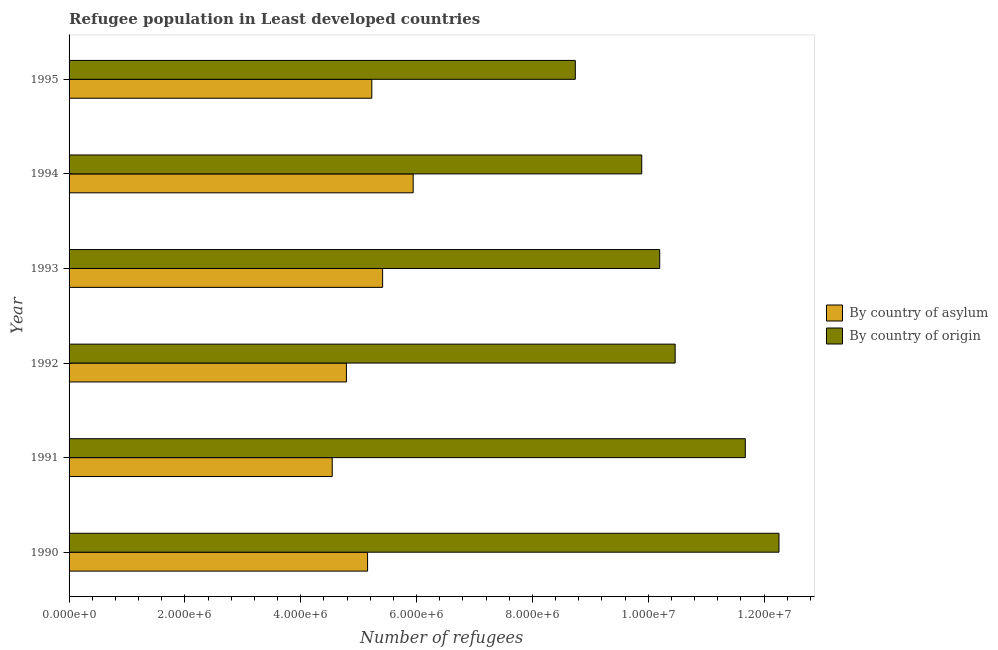How many different coloured bars are there?
Provide a succinct answer. 2. Are the number of bars per tick equal to the number of legend labels?
Your response must be concise. Yes. In how many cases, is the number of bars for a given year not equal to the number of legend labels?
Your answer should be compact. 0. What is the number of refugees by country of asylum in 1990?
Your answer should be very brief. 5.15e+06. Across all years, what is the maximum number of refugees by country of asylum?
Your response must be concise. 5.94e+06. Across all years, what is the minimum number of refugees by country of origin?
Keep it short and to the point. 8.74e+06. What is the total number of refugees by country of origin in the graph?
Provide a succinct answer. 6.32e+07. What is the difference between the number of refugees by country of origin in 1990 and that in 1995?
Your answer should be very brief. 3.52e+06. What is the difference between the number of refugees by country of asylum in 1990 and the number of refugees by country of origin in 1994?
Offer a terse response. -4.73e+06. What is the average number of refugees by country of asylum per year?
Offer a very short reply. 5.18e+06. In the year 1991, what is the difference between the number of refugees by country of asylum and number of refugees by country of origin?
Give a very brief answer. -7.13e+06. In how many years, is the number of refugees by country of asylum greater than 2800000 ?
Your answer should be compact. 6. What is the difference between the highest and the second highest number of refugees by country of asylum?
Your answer should be very brief. 5.27e+05. What is the difference between the highest and the lowest number of refugees by country of origin?
Ensure brevity in your answer.  3.52e+06. What does the 2nd bar from the top in 1991 represents?
Your answer should be very brief. By country of asylum. What does the 2nd bar from the bottom in 1995 represents?
Ensure brevity in your answer.  By country of origin. How many bars are there?
Your response must be concise. 12. Are all the bars in the graph horizontal?
Ensure brevity in your answer.  Yes. Does the graph contain any zero values?
Your answer should be very brief. No. Does the graph contain grids?
Provide a succinct answer. No. Where does the legend appear in the graph?
Offer a very short reply. Center right. How many legend labels are there?
Provide a succinct answer. 2. How are the legend labels stacked?
Offer a terse response. Vertical. What is the title of the graph?
Offer a terse response. Refugee population in Least developed countries. What is the label or title of the X-axis?
Give a very brief answer. Number of refugees. What is the label or title of the Y-axis?
Offer a very short reply. Year. What is the Number of refugees in By country of asylum in 1990?
Your answer should be compact. 5.15e+06. What is the Number of refugees in By country of origin in 1990?
Make the answer very short. 1.23e+07. What is the Number of refugees of By country of asylum in 1991?
Keep it short and to the point. 4.54e+06. What is the Number of refugees in By country of origin in 1991?
Offer a terse response. 1.17e+07. What is the Number of refugees in By country of asylum in 1992?
Offer a terse response. 4.79e+06. What is the Number of refugees of By country of origin in 1992?
Your answer should be compact. 1.05e+07. What is the Number of refugees of By country of asylum in 1993?
Your answer should be compact. 5.41e+06. What is the Number of refugees of By country of origin in 1993?
Ensure brevity in your answer.  1.02e+07. What is the Number of refugees in By country of asylum in 1994?
Provide a short and direct response. 5.94e+06. What is the Number of refugees in By country of origin in 1994?
Provide a short and direct response. 9.89e+06. What is the Number of refugees of By country of asylum in 1995?
Provide a succinct answer. 5.23e+06. What is the Number of refugees of By country of origin in 1995?
Give a very brief answer. 8.74e+06. Across all years, what is the maximum Number of refugees of By country of asylum?
Offer a very short reply. 5.94e+06. Across all years, what is the maximum Number of refugees in By country of origin?
Offer a terse response. 1.23e+07. Across all years, what is the minimum Number of refugees of By country of asylum?
Offer a very short reply. 4.54e+06. Across all years, what is the minimum Number of refugees of By country of origin?
Give a very brief answer. 8.74e+06. What is the total Number of refugees of By country of asylum in the graph?
Provide a short and direct response. 3.11e+07. What is the total Number of refugees of By country of origin in the graph?
Ensure brevity in your answer.  6.32e+07. What is the difference between the Number of refugees of By country of asylum in 1990 and that in 1991?
Keep it short and to the point. 6.10e+05. What is the difference between the Number of refugees in By country of origin in 1990 and that in 1991?
Provide a short and direct response. 5.82e+05. What is the difference between the Number of refugees in By country of asylum in 1990 and that in 1992?
Offer a terse response. 3.65e+05. What is the difference between the Number of refugees of By country of origin in 1990 and that in 1992?
Provide a succinct answer. 1.79e+06. What is the difference between the Number of refugees of By country of asylum in 1990 and that in 1993?
Provide a short and direct response. -2.60e+05. What is the difference between the Number of refugees of By country of origin in 1990 and that in 1993?
Provide a short and direct response. 2.06e+06. What is the difference between the Number of refugees in By country of asylum in 1990 and that in 1994?
Offer a very short reply. -7.87e+05. What is the difference between the Number of refugees in By country of origin in 1990 and that in 1994?
Make the answer very short. 2.37e+06. What is the difference between the Number of refugees of By country of asylum in 1990 and that in 1995?
Make the answer very short. -7.28e+04. What is the difference between the Number of refugees in By country of origin in 1990 and that in 1995?
Make the answer very short. 3.52e+06. What is the difference between the Number of refugees in By country of asylum in 1991 and that in 1992?
Provide a short and direct response. -2.45e+05. What is the difference between the Number of refugees of By country of origin in 1991 and that in 1992?
Ensure brevity in your answer.  1.21e+06. What is the difference between the Number of refugees of By country of asylum in 1991 and that in 1993?
Offer a terse response. -8.70e+05. What is the difference between the Number of refugees in By country of origin in 1991 and that in 1993?
Ensure brevity in your answer.  1.48e+06. What is the difference between the Number of refugees of By country of asylum in 1991 and that in 1994?
Offer a terse response. -1.40e+06. What is the difference between the Number of refugees in By country of origin in 1991 and that in 1994?
Your response must be concise. 1.79e+06. What is the difference between the Number of refugees in By country of asylum in 1991 and that in 1995?
Give a very brief answer. -6.83e+05. What is the difference between the Number of refugees of By country of origin in 1991 and that in 1995?
Make the answer very short. 2.94e+06. What is the difference between the Number of refugees of By country of asylum in 1992 and that in 1993?
Make the answer very short. -6.25e+05. What is the difference between the Number of refugees in By country of origin in 1992 and that in 1993?
Give a very brief answer. 2.67e+05. What is the difference between the Number of refugees of By country of asylum in 1992 and that in 1994?
Ensure brevity in your answer.  -1.15e+06. What is the difference between the Number of refugees of By country of origin in 1992 and that in 1994?
Offer a terse response. 5.77e+05. What is the difference between the Number of refugees of By country of asylum in 1992 and that in 1995?
Offer a very short reply. -4.38e+05. What is the difference between the Number of refugees in By country of origin in 1992 and that in 1995?
Keep it short and to the point. 1.72e+06. What is the difference between the Number of refugees in By country of asylum in 1993 and that in 1994?
Offer a very short reply. -5.27e+05. What is the difference between the Number of refugees in By country of origin in 1993 and that in 1994?
Provide a succinct answer. 3.10e+05. What is the difference between the Number of refugees in By country of asylum in 1993 and that in 1995?
Offer a very short reply. 1.87e+05. What is the difference between the Number of refugees of By country of origin in 1993 and that in 1995?
Offer a terse response. 1.46e+06. What is the difference between the Number of refugees of By country of asylum in 1994 and that in 1995?
Provide a short and direct response. 7.15e+05. What is the difference between the Number of refugees of By country of origin in 1994 and that in 1995?
Your answer should be very brief. 1.15e+06. What is the difference between the Number of refugees of By country of asylum in 1990 and the Number of refugees of By country of origin in 1991?
Provide a short and direct response. -6.52e+06. What is the difference between the Number of refugees of By country of asylum in 1990 and the Number of refugees of By country of origin in 1992?
Your answer should be very brief. -5.31e+06. What is the difference between the Number of refugees in By country of asylum in 1990 and the Number of refugees in By country of origin in 1993?
Provide a short and direct response. -5.04e+06. What is the difference between the Number of refugees of By country of asylum in 1990 and the Number of refugees of By country of origin in 1994?
Keep it short and to the point. -4.73e+06. What is the difference between the Number of refugees in By country of asylum in 1990 and the Number of refugees in By country of origin in 1995?
Your answer should be compact. -3.59e+06. What is the difference between the Number of refugees of By country of asylum in 1991 and the Number of refugees of By country of origin in 1992?
Your answer should be very brief. -5.92e+06. What is the difference between the Number of refugees in By country of asylum in 1991 and the Number of refugees in By country of origin in 1993?
Your answer should be very brief. -5.65e+06. What is the difference between the Number of refugees of By country of asylum in 1991 and the Number of refugees of By country of origin in 1994?
Offer a terse response. -5.34e+06. What is the difference between the Number of refugees in By country of asylum in 1991 and the Number of refugees in By country of origin in 1995?
Your answer should be compact. -4.20e+06. What is the difference between the Number of refugees in By country of asylum in 1992 and the Number of refugees in By country of origin in 1993?
Ensure brevity in your answer.  -5.41e+06. What is the difference between the Number of refugees of By country of asylum in 1992 and the Number of refugees of By country of origin in 1994?
Your response must be concise. -5.10e+06. What is the difference between the Number of refugees in By country of asylum in 1992 and the Number of refugees in By country of origin in 1995?
Offer a terse response. -3.95e+06. What is the difference between the Number of refugees in By country of asylum in 1993 and the Number of refugees in By country of origin in 1994?
Provide a succinct answer. -4.47e+06. What is the difference between the Number of refugees in By country of asylum in 1993 and the Number of refugees in By country of origin in 1995?
Offer a terse response. -3.33e+06. What is the difference between the Number of refugees in By country of asylum in 1994 and the Number of refugees in By country of origin in 1995?
Offer a terse response. -2.80e+06. What is the average Number of refugees in By country of asylum per year?
Give a very brief answer. 5.18e+06. What is the average Number of refugees of By country of origin per year?
Offer a terse response. 1.05e+07. In the year 1990, what is the difference between the Number of refugees of By country of asylum and Number of refugees of By country of origin?
Your answer should be compact. -7.10e+06. In the year 1991, what is the difference between the Number of refugees of By country of asylum and Number of refugees of By country of origin?
Provide a short and direct response. -7.13e+06. In the year 1992, what is the difference between the Number of refugees of By country of asylum and Number of refugees of By country of origin?
Give a very brief answer. -5.68e+06. In the year 1993, what is the difference between the Number of refugees in By country of asylum and Number of refugees in By country of origin?
Your answer should be very brief. -4.78e+06. In the year 1994, what is the difference between the Number of refugees in By country of asylum and Number of refugees in By country of origin?
Provide a short and direct response. -3.95e+06. In the year 1995, what is the difference between the Number of refugees of By country of asylum and Number of refugees of By country of origin?
Ensure brevity in your answer.  -3.51e+06. What is the ratio of the Number of refugees in By country of asylum in 1990 to that in 1991?
Your answer should be compact. 1.13. What is the ratio of the Number of refugees in By country of origin in 1990 to that in 1991?
Provide a short and direct response. 1.05. What is the ratio of the Number of refugees of By country of asylum in 1990 to that in 1992?
Give a very brief answer. 1.08. What is the ratio of the Number of refugees of By country of origin in 1990 to that in 1992?
Offer a terse response. 1.17. What is the ratio of the Number of refugees of By country of asylum in 1990 to that in 1993?
Provide a succinct answer. 0.95. What is the ratio of the Number of refugees in By country of origin in 1990 to that in 1993?
Provide a short and direct response. 1.2. What is the ratio of the Number of refugees of By country of asylum in 1990 to that in 1994?
Ensure brevity in your answer.  0.87. What is the ratio of the Number of refugees of By country of origin in 1990 to that in 1994?
Ensure brevity in your answer.  1.24. What is the ratio of the Number of refugees of By country of asylum in 1990 to that in 1995?
Keep it short and to the point. 0.99. What is the ratio of the Number of refugees of By country of origin in 1990 to that in 1995?
Provide a succinct answer. 1.4. What is the ratio of the Number of refugees of By country of asylum in 1991 to that in 1992?
Keep it short and to the point. 0.95. What is the ratio of the Number of refugees of By country of origin in 1991 to that in 1992?
Offer a terse response. 1.12. What is the ratio of the Number of refugees of By country of asylum in 1991 to that in 1993?
Offer a very short reply. 0.84. What is the ratio of the Number of refugees in By country of origin in 1991 to that in 1993?
Your answer should be compact. 1.14. What is the ratio of the Number of refugees of By country of asylum in 1991 to that in 1994?
Give a very brief answer. 0.76. What is the ratio of the Number of refugees of By country of origin in 1991 to that in 1994?
Ensure brevity in your answer.  1.18. What is the ratio of the Number of refugees of By country of asylum in 1991 to that in 1995?
Give a very brief answer. 0.87. What is the ratio of the Number of refugees in By country of origin in 1991 to that in 1995?
Offer a terse response. 1.34. What is the ratio of the Number of refugees in By country of asylum in 1992 to that in 1993?
Your answer should be very brief. 0.88. What is the ratio of the Number of refugees of By country of origin in 1992 to that in 1993?
Make the answer very short. 1.03. What is the ratio of the Number of refugees in By country of asylum in 1992 to that in 1994?
Your response must be concise. 0.81. What is the ratio of the Number of refugees of By country of origin in 1992 to that in 1994?
Offer a very short reply. 1.06. What is the ratio of the Number of refugees of By country of asylum in 1992 to that in 1995?
Give a very brief answer. 0.92. What is the ratio of the Number of refugees in By country of origin in 1992 to that in 1995?
Offer a very short reply. 1.2. What is the ratio of the Number of refugees in By country of asylum in 1993 to that in 1994?
Your answer should be compact. 0.91. What is the ratio of the Number of refugees in By country of origin in 1993 to that in 1994?
Give a very brief answer. 1.03. What is the ratio of the Number of refugees in By country of asylum in 1993 to that in 1995?
Offer a very short reply. 1.04. What is the ratio of the Number of refugees of By country of origin in 1993 to that in 1995?
Your response must be concise. 1.17. What is the ratio of the Number of refugees of By country of asylum in 1994 to that in 1995?
Keep it short and to the point. 1.14. What is the ratio of the Number of refugees of By country of origin in 1994 to that in 1995?
Provide a succinct answer. 1.13. What is the difference between the highest and the second highest Number of refugees in By country of asylum?
Provide a short and direct response. 5.27e+05. What is the difference between the highest and the second highest Number of refugees in By country of origin?
Keep it short and to the point. 5.82e+05. What is the difference between the highest and the lowest Number of refugees of By country of asylum?
Your answer should be compact. 1.40e+06. What is the difference between the highest and the lowest Number of refugees of By country of origin?
Ensure brevity in your answer.  3.52e+06. 